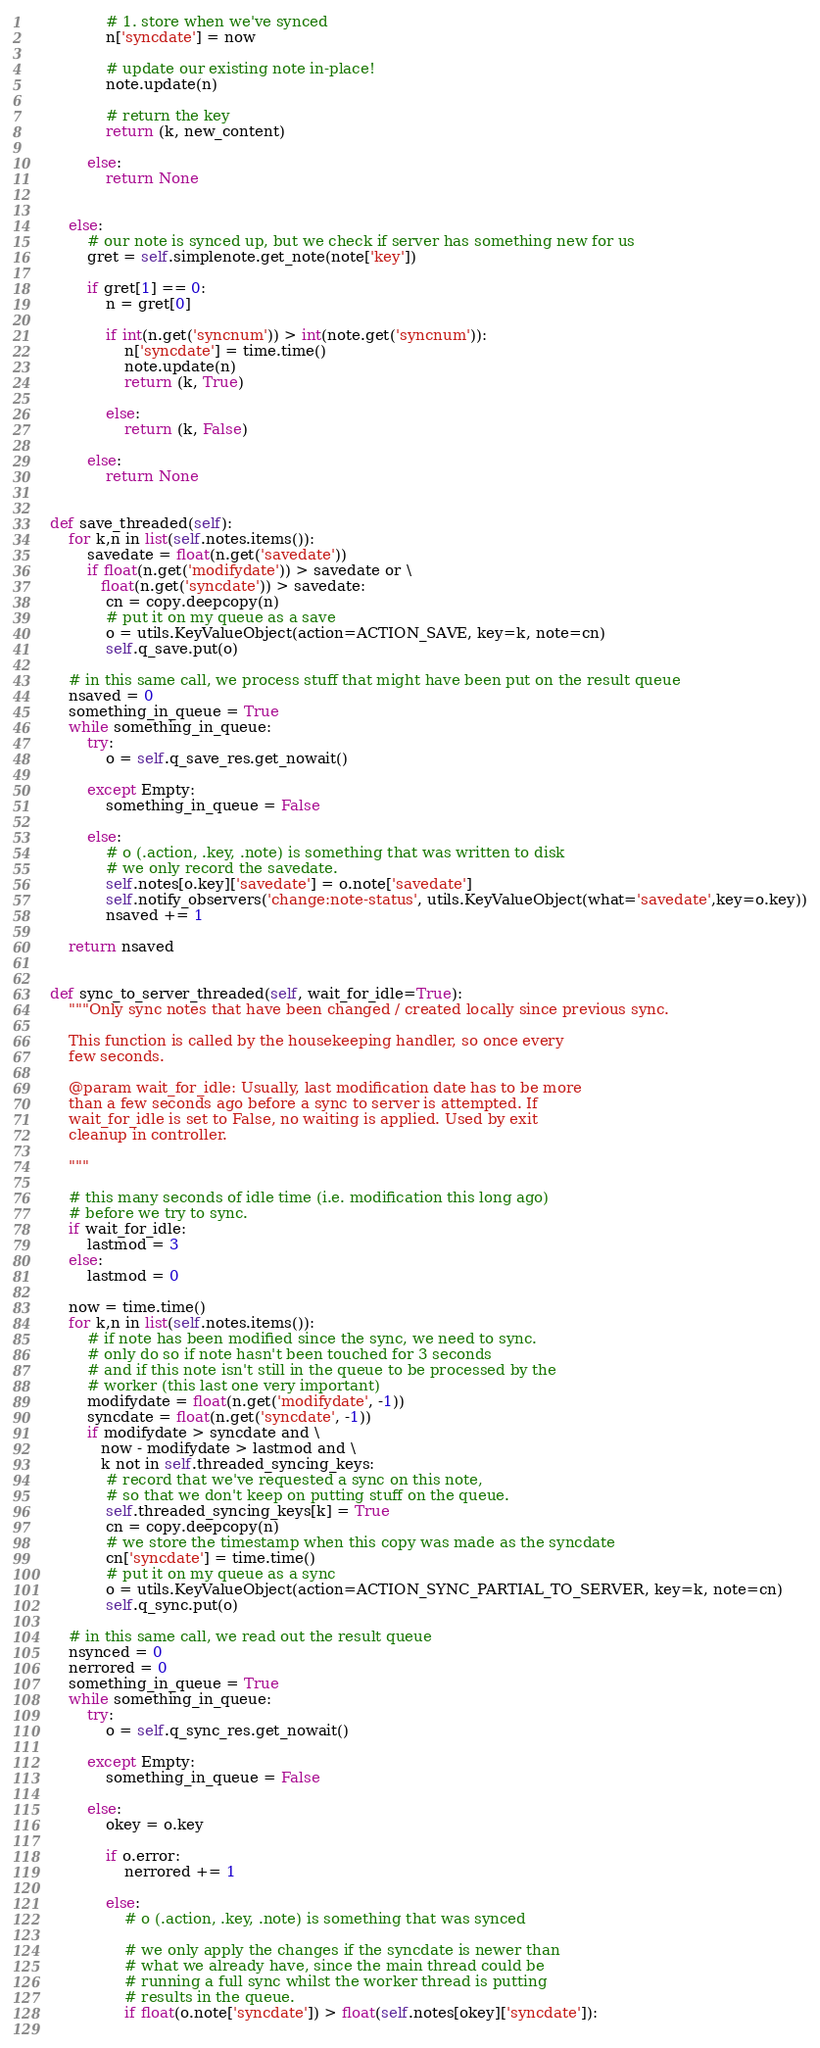Convert code to text. <code><loc_0><loc_0><loc_500><loc_500><_Python_>                # 1. store when we've synced
                n['syncdate'] = now
                
                # update our existing note in-place!
                note.update(n)
        
                # return the key
                return (k, new_content)
                
            else:
                return None

            
        else:
            # our note is synced up, but we check if server has something new for us
            gret = self.simplenote.get_note(note['key'])
            
            if gret[1] == 0:
                n = gret[0]
                
                if int(n.get('syncnum')) > int(note.get('syncnum')):
                    n['syncdate'] = time.time()
                    note.update(n)
                    return (k, True)
                
                else:
                    return (k, False)

            else:
                return None

        
    def save_threaded(self):
        for k,n in list(self.notes.items()):
            savedate = float(n.get('savedate'))
            if float(n.get('modifydate')) > savedate or \
               float(n.get('syncdate')) > savedate:
                cn = copy.deepcopy(n)
                # put it on my queue as a save
                o = utils.KeyValueObject(action=ACTION_SAVE, key=k, note=cn)
                self.q_save.put(o)
                
        # in this same call, we process stuff that might have been put on the result queue
        nsaved = 0
        something_in_queue = True
        while something_in_queue:
            try:
                o = self.q_save_res.get_nowait()
                
            except Empty:
                something_in_queue = False
                
            else:
                # o (.action, .key, .note) is something that was written to disk
                # we only record the savedate.
                self.notes[o.key]['savedate'] = o.note['savedate']
                self.notify_observers('change:note-status', utils.KeyValueObject(what='savedate',key=o.key))
                nsaved += 1
                
        return nsaved
        
    
    def sync_to_server_threaded(self, wait_for_idle=True):
        """Only sync notes that have been changed / created locally since previous sync.
        
        This function is called by the housekeeping handler, so once every
        few seconds.
        
        @param wait_for_idle: Usually, last modification date has to be more
        than a few seconds ago before a sync to server is attempted. If
        wait_for_idle is set to False, no waiting is applied. Used by exit
        cleanup in controller.
        
        """
        
        # this many seconds of idle time (i.e. modification this long ago)
        # before we try to sync.
        if wait_for_idle:
            lastmod = 3
        else:
            lastmod = 0
        
        now = time.time()
        for k,n in list(self.notes.items()):
            # if note has been modified since the sync, we need to sync.
            # only do so if note hasn't been touched for 3 seconds
            # and if this note isn't still in the queue to be processed by the
            # worker (this last one very important)
            modifydate = float(n.get('modifydate', -1))
            syncdate = float(n.get('syncdate', -1))
            if modifydate > syncdate and \
               now - modifydate > lastmod and \
               k not in self.threaded_syncing_keys:
                # record that we've requested a sync on this note,
                # so that we don't keep on putting stuff on the queue.
                self.threaded_syncing_keys[k] = True
                cn = copy.deepcopy(n)
                # we store the timestamp when this copy was made as the syncdate
                cn['syncdate'] = time.time()
                # put it on my queue as a sync
                o = utils.KeyValueObject(action=ACTION_SYNC_PARTIAL_TO_SERVER, key=k, note=cn)
                self.q_sync.put(o)
                
        # in this same call, we read out the result queue
        nsynced = 0
        nerrored = 0
        something_in_queue = True
        while something_in_queue:
            try:
                o = self.q_sync_res.get_nowait()
                
            except Empty:
                something_in_queue = False
                
            else:
                okey = o.key

                if o.error:
                    nerrored += 1
                    
                else:
                    # o (.action, .key, .note) is something that was synced

                    # we only apply the changes if the syncdate is newer than
                    # what we already have, since the main thread could be
                    # running a full sync whilst the worker thread is putting
                    # results in the queue.
                    if float(o.note['syncdate']) > float(self.notes[okey]['syncdate']):
                                        </code> 